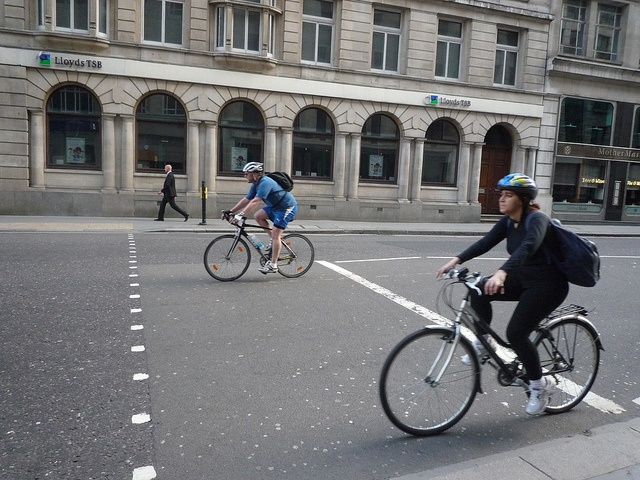Describe the objects in this image and their specific colors. I can see bicycle in gray, black, and lightgray tones, people in gray, black, and darkgray tones, bicycle in gray and black tones, people in gray, black, navy, and darkgray tones, and backpack in gray, black, and darkgray tones in this image. 